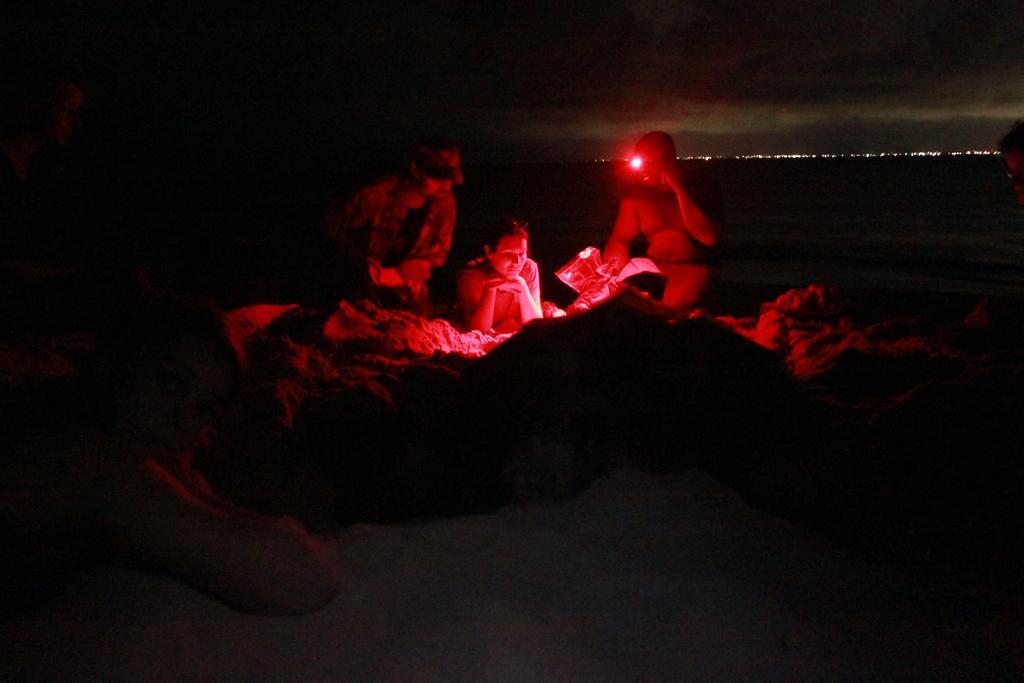In one or two sentences, can you explain what this image depicts? In this image there are people on the land. Bottom of the image a person is lying on the land. Background there are lights. Top of the image there is sky. Right side there is a person having a light. He is holding an object. 